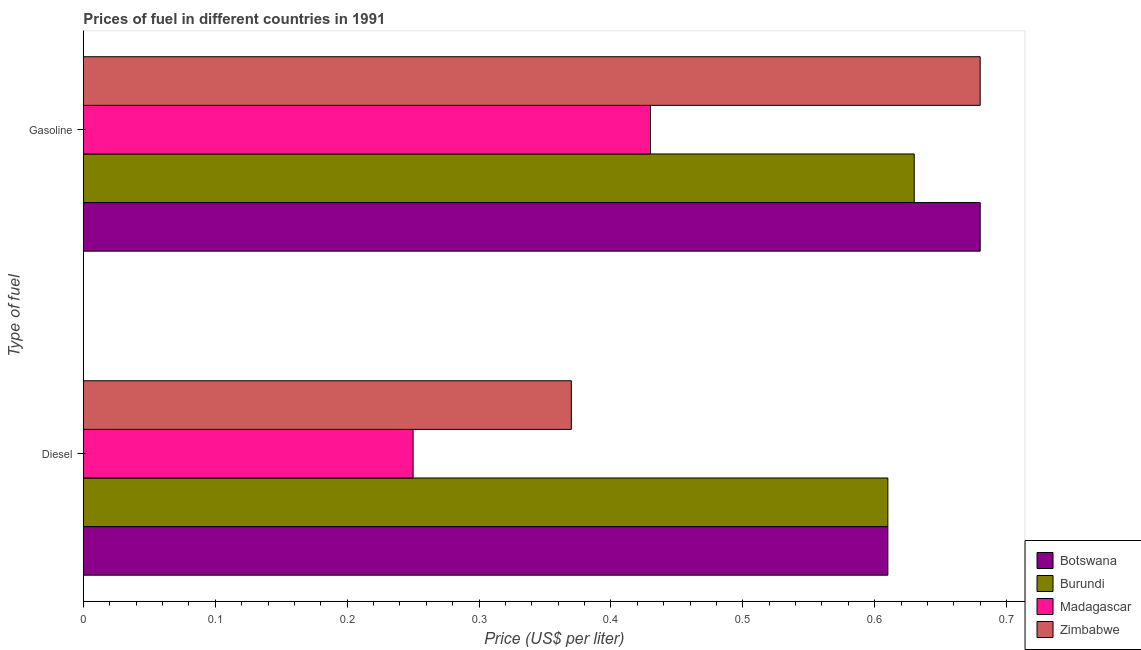How many different coloured bars are there?
Your answer should be compact. 4. How many groups of bars are there?
Provide a short and direct response. 2. Are the number of bars per tick equal to the number of legend labels?
Your answer should be very brief. Yes. How many bars are there on the 1st tick from the top?
Ensure brevity in your answer.  4. How many bars are there on the 1st tick from the bottom?
Give a very brief answer. 4. What is the label of the 1st group of bars from the top?
Your answer should be compact. Gasoline. What is the diesel price in Zimbabwe?
Ensure brevity in your answer.  0.37. Across all countries, what is the maximum diesel price?
Keep it short and to the point. 0.61. In which country was the gasoline price maximum?
Your answer should be compact. Botswana. In which country was the diesel price minimum?
Make the answer very short. Madagascar. What is the total diesel price in the graph?
Provide a succinct answer. 1.84. What is the difference between the diesel price in Zimbabwe and that in Burundi?
Give a very brief answer. -0.24. What is the difference between the diesel price in Botswana and the gasoline price in Burundi?
Offer a very short reply. -0.02. What is the average gasoline price per country?
Ensure brevity in your answer.  0.6. What is the difference between the diesel price and gasoline price in Madagascar?
Your answer should be compact. -0.18. In how many countries, is the diesel price greater than 0.06 US$ per litre?
Keep it short and to the point. 4. What is the ratio of the gasoline price in Madagascar to that in Botswana?
Keep it short and to the point. 0.63. Is the gasoline price in Madagascar less than that in Botswana?
Keep it short and to the point. Yes. In how many countries, is the gasoline price greater than the average gasoline price taken over all countries?
Offer a terse response. 3. What does the 2nd bar from the top in Gasoline represents?
Keep it short and to the point. Madagascar. What does the 3rd bar from the bottom in Gasoline represents?
Your response must be concise. Madagascar. How many countries are there in the graph?
Provide a succinct answer. 4. Are the values on the major ticks of X-axis written in scientific E-notation?
Offer a terse response. No. Where does the legend appear in the graph?
Your response must be concise. Bottom right. How are the legend labels stacked?
Make the answer very short. Vertical. What is the title of the graph?
Your answer should be compact. Prices of fuel in different countries in 1991. Does "Niger" appear as one of the legend labels in the graph?
Give a very brief answer. No. What is the label or title of the X-axis?
Give a very brief answer. Price (US$ per liter). What is the label or title of the Y-axis?
Provide a succinct answer. Type of fuel. What is the Price (US$ per liter) of Botswana in Diesel?
Your answer should be compact. 0.61. What is the Price (US$ per liter) of Burundi in Diesel?
Your answer should be very brief. 0.61. What is the Price (US$ per liter) of Zimbabwe in Diesel?
Offer a very short reply. 0.37. What is the Price (US$ per liter) in Botswana in Gasoline?
Provide a succinct answer. 0.68. What is the Price (US$ per liter) in Burundi in Gasoline?
Your response must be concise. 0.63. What is the Price (US$ per liter) of Madagascar in Gasoline?
Your response must be concise. 0.43. What is the Price (US$ per liter) in Zimbabwe in Gasoline?
Your answer should be very brief. 0.68. Across all Type of fuel, what is the maximum Price (US$ per liter) in Botswana?
Provide a short and direct response. 0.68. Across all Type of fuel, what is the maximum Price (US$ per liter) of Burundi?
Ensure brevity in your answer.  0.63. Across all Type of fuel, what is the maximum Price (US$ per liter) of Madagascar?
Your answer should be compact. 0.43. Across all Type of fuel, what is the maximum Price (US$ per liter) in Zimbabwe?
Your answer should be compact. 0.68. Across all Type of fuel, what is the minimum Price (US$ per liter) in Botswana?
Offer a very short reply. 0.61. Across all Type of fuel, what is the minimum Price (US$ per liter) in Burundi?
Your answer should be compact. 0.61. Across all Type of fuel, what is the minimum Price (US$ per liter) in Zimbabwe?
Provide a short and direct response. 0.37. What is the total Price (US$ per liter) of Botswana in the graph?
Offer a terse response. 1.29. What is the total Price (US$ per liter) of Burundi in the graph?
Your answer should be compact. 1.24. What is the total Price (US$ per liter) in Madagascar in the graph?
Provide a short and direct response. 0.68. What is the total Price (US$ per liter) of Zimbabwe in the graph?
Your answer should be very brief. 1.05. What is the difference between the Price (US$ per liter) of Botswana in Diesel and that in Gasoline?
Provide a succinct answer. -0.07. What is the difference between the Price (US$ per liter) in Burundi in Diesel and that in Gasoline?
Keep it short and to the point. -0.02. What is the difference between the Price (US$ per liter) in Madagascar in Diesel and that in Gasoline?
Provide a short and direct response. -0.18. What is the difference between the Price (US$ per liter) of Zimbabwe in Diesel and that in Gasoline?
Ensure brevity in your answer.  -0.31. What is the difference between the Price (US$ per liter) of Botswana in Diesel and the Price (US$ per liter) of Burundi in Gasoline?
Your answer should be compact. -0.02. What is the difference between the Price (US$ per liter) of Botswana in Diesel and the Price (US$ per liter) of Madagascar in Gasoline?
Your answer should be compact. 0.18. What is the difference between the Price (US$ per liter) in Botswana in Diesel and the Price (US$ per liter) in Zimbabwe in Gasoline?
Your response must be concise. -0.07. What is the difference between the Price (US$ per liter) of Burundi in Diesel and the Price (US$ per liter) of Madagascar in Gasoline?
Offer a very short reply. 0.18. What is the difference between the Price (US$ per liter) in Burundi in Diesel and the Price (US$ per liter) in Zimbabwe in Gasoline?
Provide a short and direct response. -0.07. What is the difference between the Price (US$ per liter) of Madagascar in Diesel and the Price (US$ per liter) of Zimbabwe in Gasoline?
Keep it short and to the point. -0.43. What is the average Price (US$ per liter) of Botswana per Type of fuel?
Offer a very short reply. 0.65. What is the average Price (US$ per liter) of Burundi per Type of fuel?
Offer a terse response. 0.62. What is the average Price (US$ per liter) in Madagascar per Type of fuel?
Make the answer very short. 0.34. What is the average Price (US$ per liter) in Zimbabwe per Type of fuel?
Provide a short and direct response. 0.53. What is the difference between the Price (US$ per liter) in Botswana and Price (US$ per liter) in Madagascar in Diesel?
Give a very brief answer. 0.36. What is the difference between the Price (US$ per liter) of Botswana and Price (US$ per liter) of Zimbabwe in Diesel?
Make the answer very short. 0.24. What is the difference between the Price (US$ per liter) of Burundi and Price (US$ per liter) of Madagascar in Diesel?
Offer a very short reply. 0.36. What is the difference between the Price (US$ per liter) in Burundi and Price (US$ per liter) in Zimbabwe in Diesel?
Give a very brief answer. 0.24. What is the difference between the Price (US$ per liter) of Madagascar and Price (US$ per liter) of Zimbabwe in Diesel?
Provide a short and direct response. -0.12. What is the difference between the Price (US$ per liter) in Botswana and Price (US$ per liter) in Madagascar in Gasoline?
Your answer should be compact. 0.25. What is the ratio of the Price (US$ per liter) in Botswana in Diesel to that in Gasoline?
Provide a succinct answer. 0.9. What is the ratio of the Price (US$ per liter) in Burundi in Diesel to that in Gasoline?
Make the answer very short. 0.97. What is the ratio of the Price (US$ per liter) in Madagascar in Diesel to that in Gasoline?
Your answer should be compact. 0.58. What is the ratio of the Price (US$ per liter) in Zimbabwe in Diesel to that in Gasoline?
Give a very brief answer. 0.54. What is the difference between the highest and the second highest Price (US$ per liter) in Botswana?
Give a very brief answer. 0.07. What is the difference between the highest and the second highest Price (US$ per liter) in Madagascar?
Ensure brevity in your answer.  0.18. What is the difference between the highest and the second highest Price (US$ per liter) in Zimbabwe?
Your answer should be compact. 0.31. What is the difference between the highest and the lowest Price (US$ per liter) in Botswana?
Provide a short and direct response. 0.07. What is the difference between the highest and the lowest Price (US$ per liter) in Madagascar?
Give a very brief answer. 0.18. What is the difference between the highest and the lowest Price (US$ per liter) in Zimbabwe?
Your answer should be very brief. 0.31. 